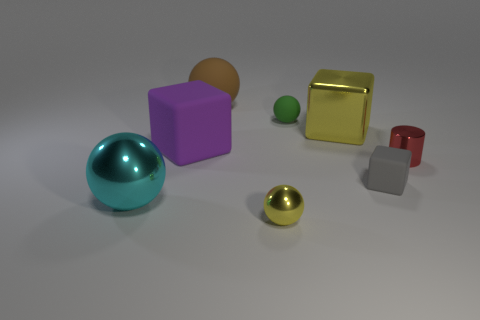Do the cyan shiny object and the large brown matte thing have the same shape?
Keep it short and to the point. Yes. The cube that is both right of the large matte ball and behind the tiny red object is made of what material?
Offer a very short reply. Metal. What number of other things have the same shape as the large brown matte object?
Provide a succinct answer. 3. How big is the ball to the right of the tiny metallic thing that is in front of the rubber block to the right of the big brown matte thing?
Make the answer very short. Small. Are there more yellow balls that are in front of the small red metallic object than blue matte spheres?
Your answer should be very brief. Yes. Is there a blue rubber ball?
Your answer should be compact. No. What number of green balls are the same size as the cylinder?
Provide a short and direct response. 1. Are there more large rubber objects behind the tiny green sphere than red cylinders that are behind the red object?
Provide a short and direct response. Yes. There is a yellow object that is the same size as the green ball; what is its material?
Make the answer very short. Metal. There is a brown rubber thing; what shape is it?
Provide a short and direct response. Sphere. 